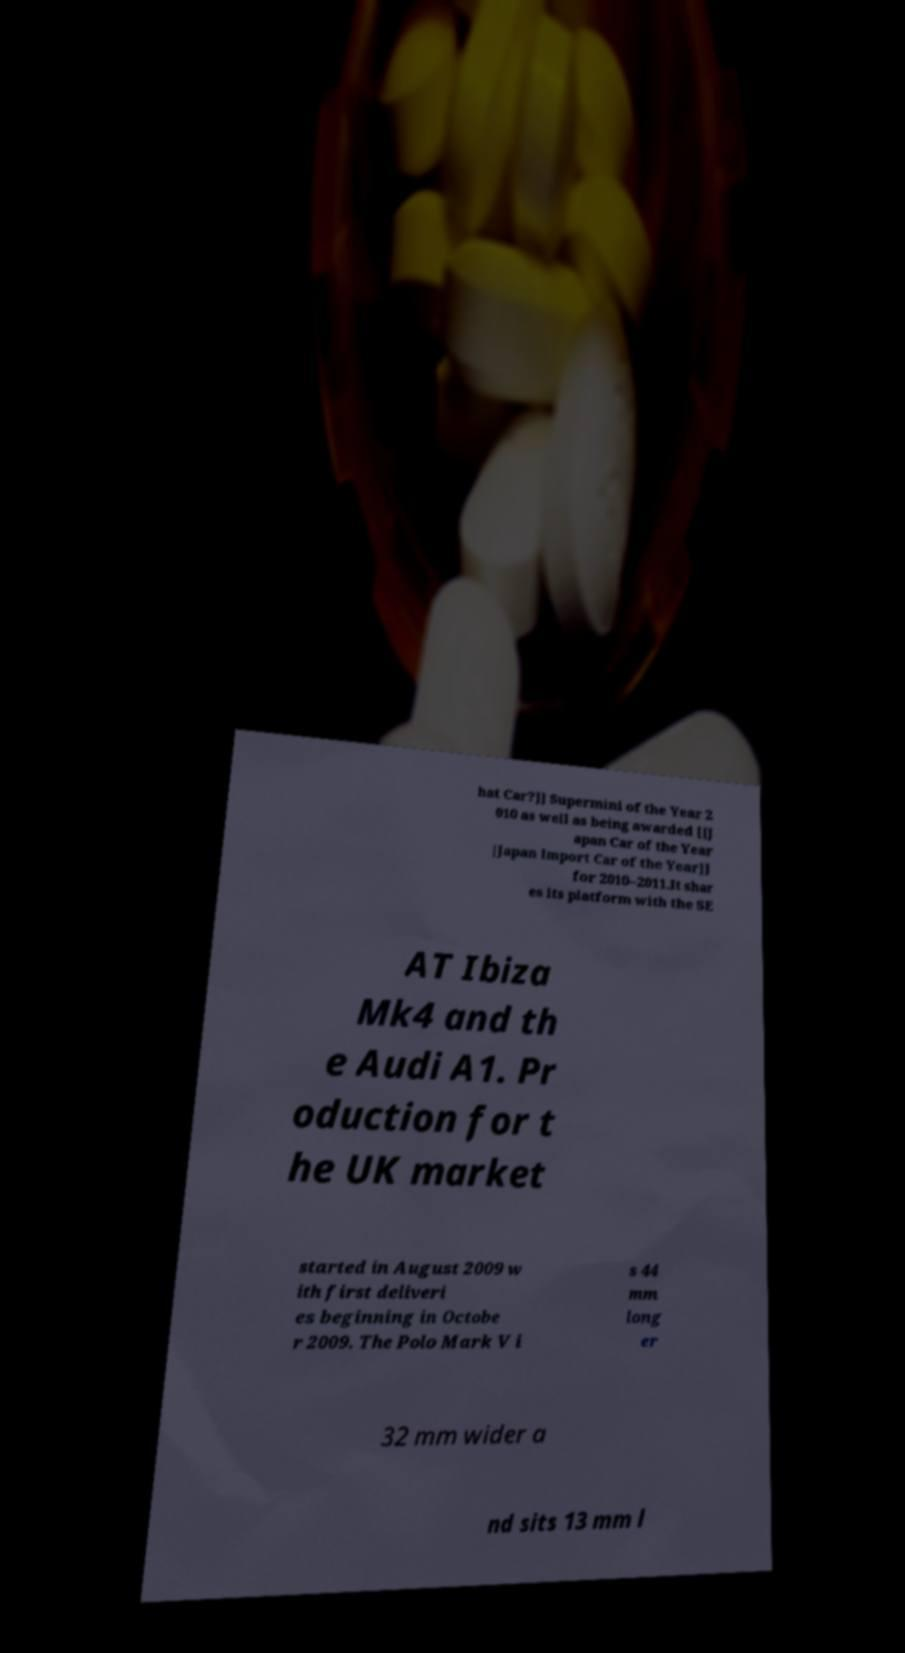For documentation purposes, I need the text within this image transcribed. Could you provide that? hat Car?]] Supermini of the Year 2 010 as well as being awarded [[J apan Car of the Year |Japan Import Car of the Year]] for 2010–2011.It shar es its platform with the SE AT Ibiza Mk4 and th e Audi A1. Pr oduction for t he UK market started in August 2009 w ith first deliveri es beginning in Octobe r 2009. The Polo Mark V i s 44 mm long er 32 mm wider a nd sits 13 mm l 